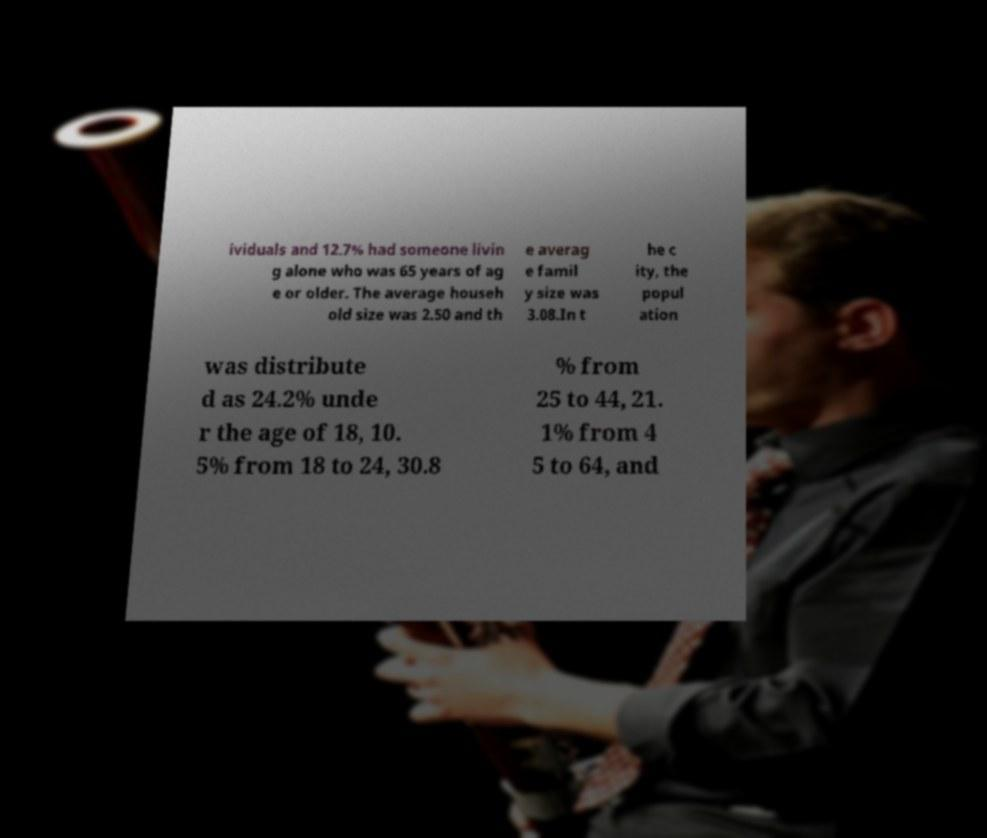Please read and relay the text visible in this image. What does it say? ividuals and 12.7% had someone livin g alone who was 65 years of ag e or older. The average househ old size was 2.50 and th e averag e famil y size was 3.08.In t he c ity, the popul ation was distribute d as 24.2% unde r the age of 18, 10. 5% from 18 to 24, 30.8 % from 25 to 44, 21. 1% from 4 5 to 64, and 